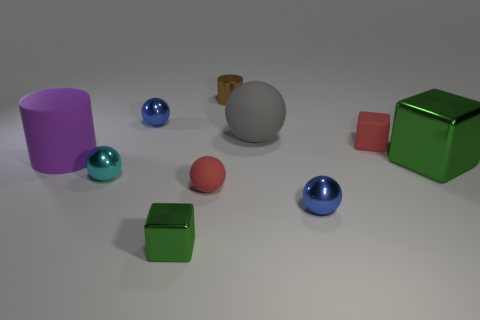What could possibly be the source of the light in the scene, as there are shadows visible? The light source in the scene is not directly visible, but based on the uniformly soft shadows cast by the objects, it appears to come from above. The diffuse nature of the shadows suggests that the light source is expansive, or there could be multiple sources contributing to the overall illumination, similar to ambient lighting found in a photography studio. 